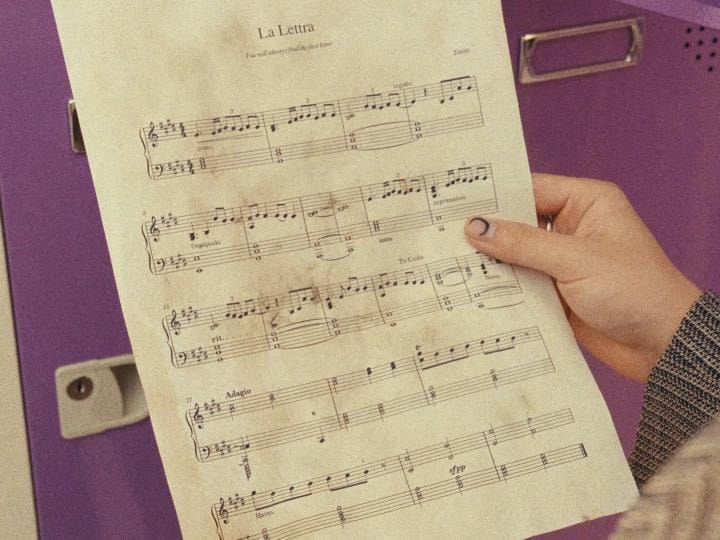What's unusual about the image? The image is unusual because it shows a person holding sheet music with a black crescent moon painted on their fingernail. It's a bit of a quirky juxtaposition of the traditional and the modern, and the image makes you wonder about the person's personality and style. 